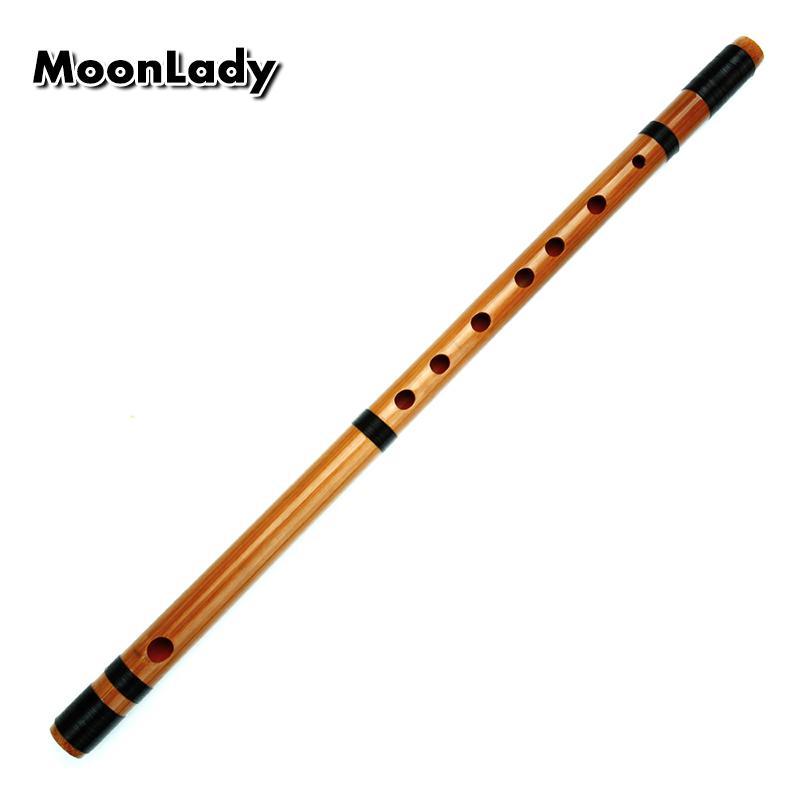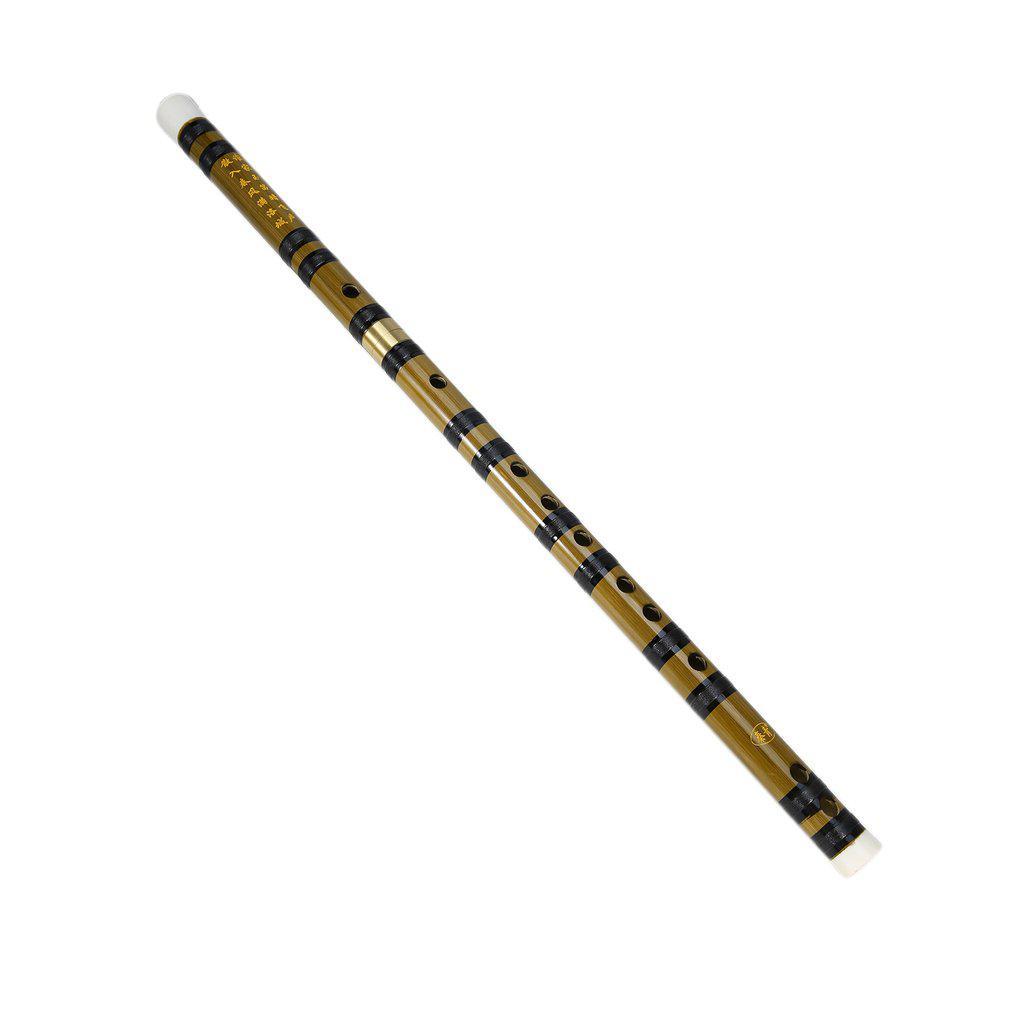The first image is the image on the left, the second image is the image on the right. Evaluate the accuracy of this statement regarding the images: "The left image contains a single flute displayed at an angle, and the right image contains at least one flute displayed at an angle opposite that of the flute on the left.". Is it true? Answer yes or no. Yes. The first image is the image on the left, the second image is the image on the right. Considering the images on both sides, is "There are two flutes in the left image." valid? Answer yes or no. No. 